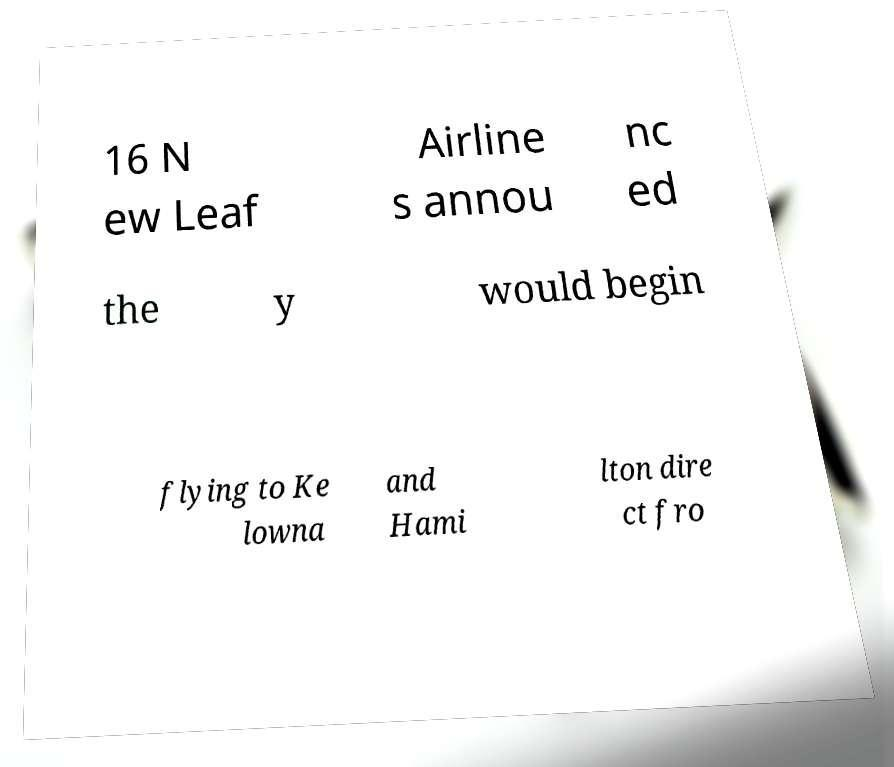Can you read and provide the text displayed in the image?This photo seems to have some interesting text. Can you extract and type it out for me? 16 N ew Leaf Airline s annou nc ed the y would begin flying to Ke lowna and Hami lton dire ct fro 